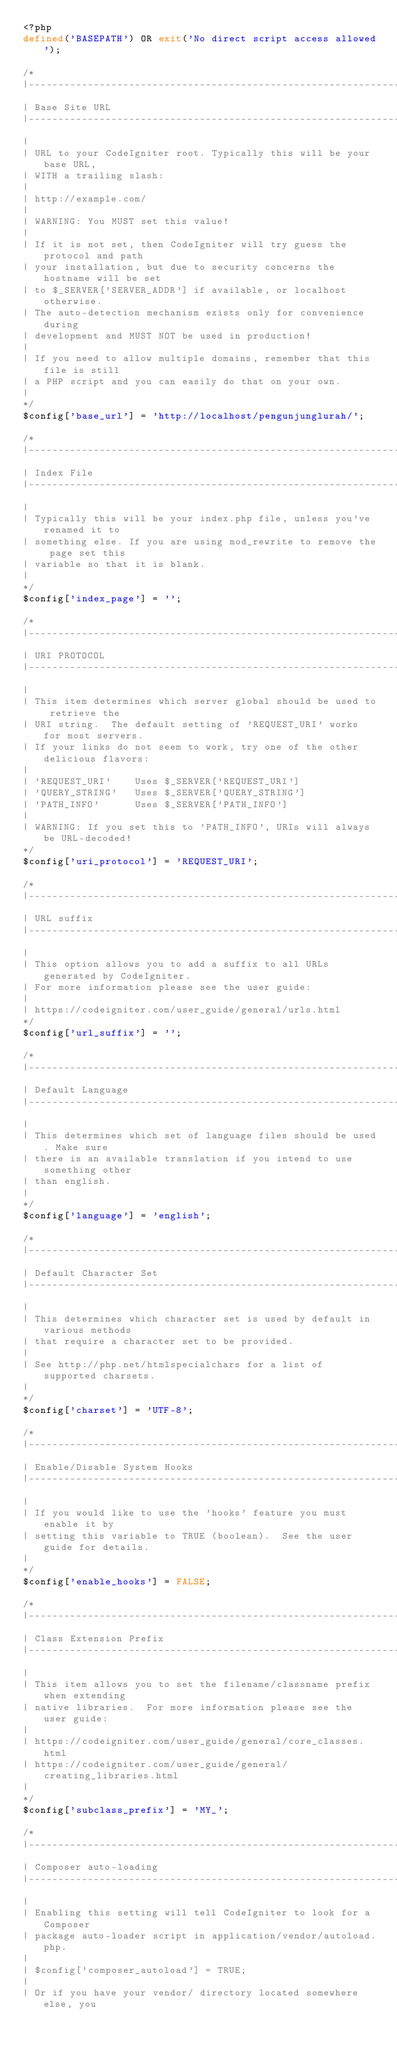Convert code to text. <code><loc_0><loc_0><loc_500><loc_500><_PHP_><?php
defined('BASEPATH') OR exit('No direct script access allowed');

/*
|--------------------------------------------------------------------------
| Base Site URL
|--------------------------------------------------------------------------
|
| URL to your CodeIgniter root. Typically this will be your base URL,
| WITH a trailing slash:
|
|	http://example.com/
|
| WARNING: You MUST set this value!
|
| If it is not set, then CodeIgniter will try guess the protocol and path
| your installation, but due to security concerns the hostname will be set
| to $_SERVER['SERVER_ADDR'] if available, or localhost otherwise.
| The auto-detection mechanism exists only for convenience during
| development and MUST NOT be used in production!
|
| If you need to allow multiple domains, remember that this file is still
| a PHP script and you can easily do that on your own.
|
*/
$config['base_url'] = 'http://localhost/pengunjunglurah/';

/*
|--------------------------------------------------------------------------
| Index File
|--------------------------------------------------------------------------
|
| Typically this will be your index.php file, unless you've renamed it to
| something else. If you are using mod_rewrite to remove the page set this
| variable so that it is blank.
|
*/
$config['index_page'] = '';

/*
|--------------------------------------------------------------------------
| URI PROTOCOL
|--------------------------------------------------------------------------
|
| This item determines which server global should be used to retrieve the
| URI string.  The default setting of 'REQUEST_URI' works for most servers.
| If your links do not seem to work, try one of the other delicious flavors:
|
| 'REQUEST_URI'    Uses $_SERVER['REQUEST_URI']
| 'QUERY_STRING'   Uses $_SERVER['QUERY_STRING']
| 'PATH_INFO'      Uses $_SERVER['PATH_INFO']
|
| WARNING: If you set this to 'PATH_INFO', URIs will always be URL-decoded!
*/
$config['uri_protocol']	= 'REQUEST_URI';

/*
|--------------------------------------------------------------------------
| URL suffix
|--------------------------------------------------------------------------
|
| This option allows you to add a suffix to all URLs generated by CodeIgniter.
| For more information please see the user guide:
|
| https://codeigniter.com/user_guide/general/urls.html
*/
$config['url_suffix'] = '';

/*
|--------------------------------------------------------------------------
| Default Language
|--------------------------------------------------------------------------
|
| This determines which set of language files should be used. Make sure
| there is an available translation if you intend to use something other
| than english.
|
*/
$config['language']	= 'english';

/*
|--------------------------------------------------------------------------
| Default Character Set
|--------------------------------------------------------------------------
|
| This determines which character set is used by default in various methods
| that require a character set to be provided.
|
| See http://php.net/htmlspecialchars for a list of supported charsets.
|
*/
$config['charset'] = 'UTF-8';

/*
|--------------------------------------------------------------------------
| Enable/Disable System Hooks
|--------------------------------------------------------------------------
|
| If you would like to use the 'hooks' feature you must enable it by
| setting this variable to TRUE (boolean).  See the user guide for details.
|
*/
$config['enable_hooks'] = FALSE;

/*
|--------------------------------------------------------------------------
| Class Extension Prefix
|--------------------------------------------------------------------------
|
| This item allows you to set the filename/classname prefix when extending
| native libraries.  For more information please see the user guide:
|
| https://codeigniter.com/user_guide/general/core_classes.html
| https://codeigniter.com/user_guide/general/creating_libraries.html
|
*/
$config['subclass_prefix'] = 'MY_';

/*
|--------------------------------------------------------------------------
| Composer auto-loading
|--------------------------------------------------------------------------
|
| Enabling this setting will tell CodeIgniter to look for a Composer
| package auto-loader script in application/vendor/autoload.php.
|
|	$config['composer_autoload'] = TRUE;
|
| Or if you have your vendor/ directory located somewhere else, you</code> 